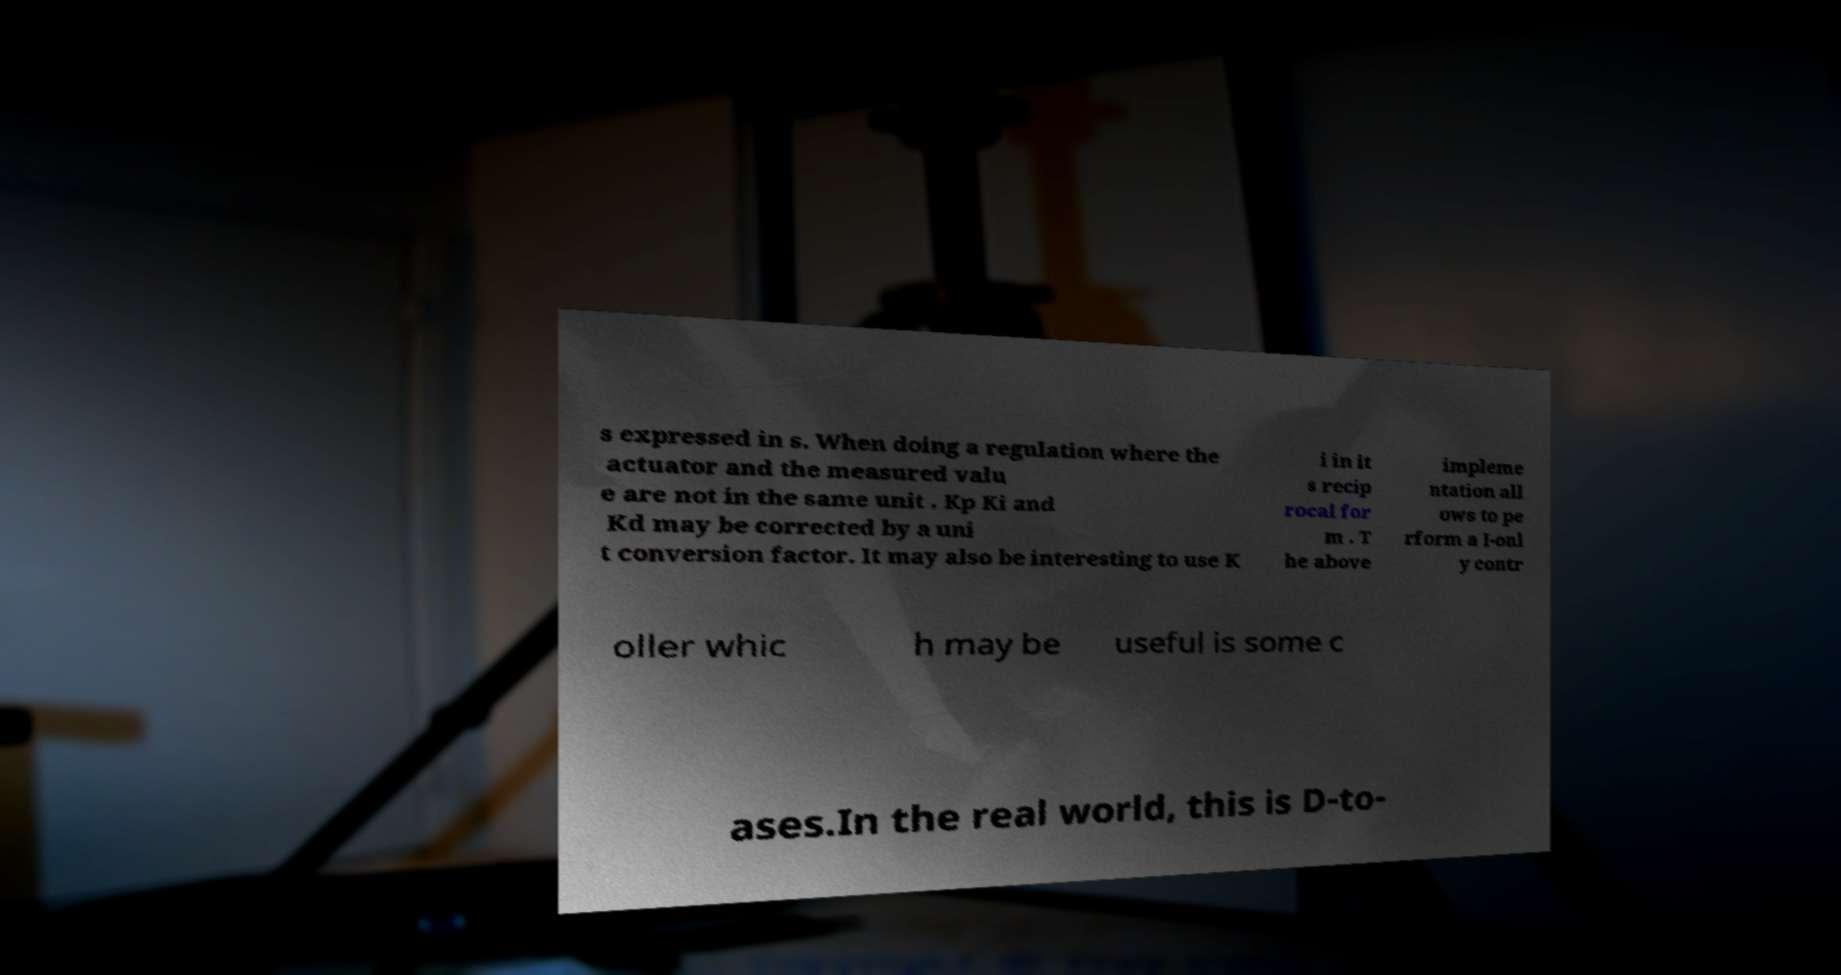Please read and relay the text visible in this image. What does it say? s expressed in s. When doing a regulation where the actuator and the measured valu e are not in the same unit . Kp Ki and Kd may be corrected by a uni t conversion factor. It may also be interesting to use K i in it s recip rocal for m . T he above impleme ntation all ows to pe rform a I-onl y contr oller whic h may be useful is some c ases.In the real world, this is D-to- 